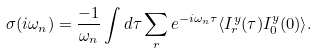<formula> <loc_0><loc_0><loc_500><loc_500>\sigma ( i \omega _ { n } ) = \frac { - 1 } { \omega _ { n } } \int d \tau \sum _ { r } e ^ { - i \omega _ { n } \tau } \langle I ^ { y } _ { r } ( \tau ) I ^ { y } _ { 0 } ( 0 ) \rangle .</formula> 